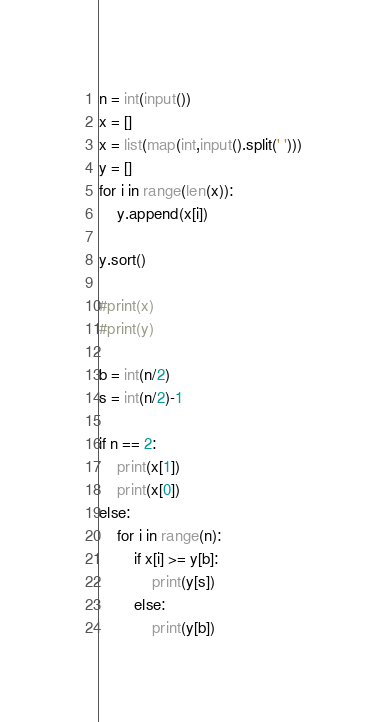Convert code to text. <code><loc_0><loc_0><loc_500><loc_500><_Python_>n = int(input())
x = []
x = list(map(int,input().split(' ')))
y = []
for i in range(len(x)):
    y.append(x[i])

y.sort()

#print(x)
#print(y)

b = int(n/2)
s = int(n/2)-1

if n == 2:
    print(x[1])
    print(x[0])
else:
    for i in range(n):
        if x[i] >= y[b]:
            print(y[s])
        else:
            print(y[b])
</code> 